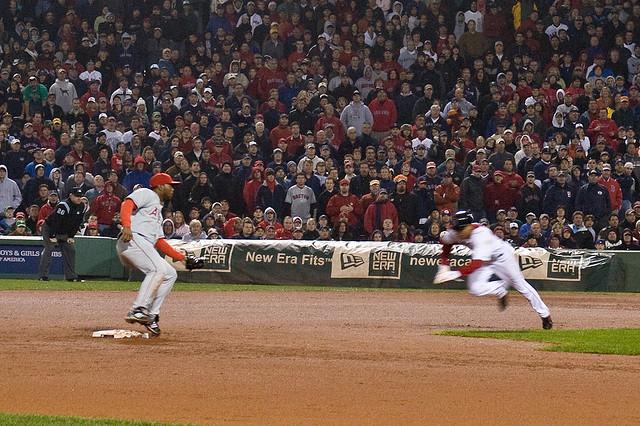Is there a large crowd?
Write a very short answer. Yes. Where is the referee?
Concise answer only. Left. Is there a pitcher here?
Concise answer only. No. What color is the ground?
Short answer required. Brown. How crowded is the stadium?
Be succinct. Very crowded. What sport is being played?
Keep it brief. Baseball. What color long sleeve shirt is the player on the left wearing?
Concise answer only. Orange. 